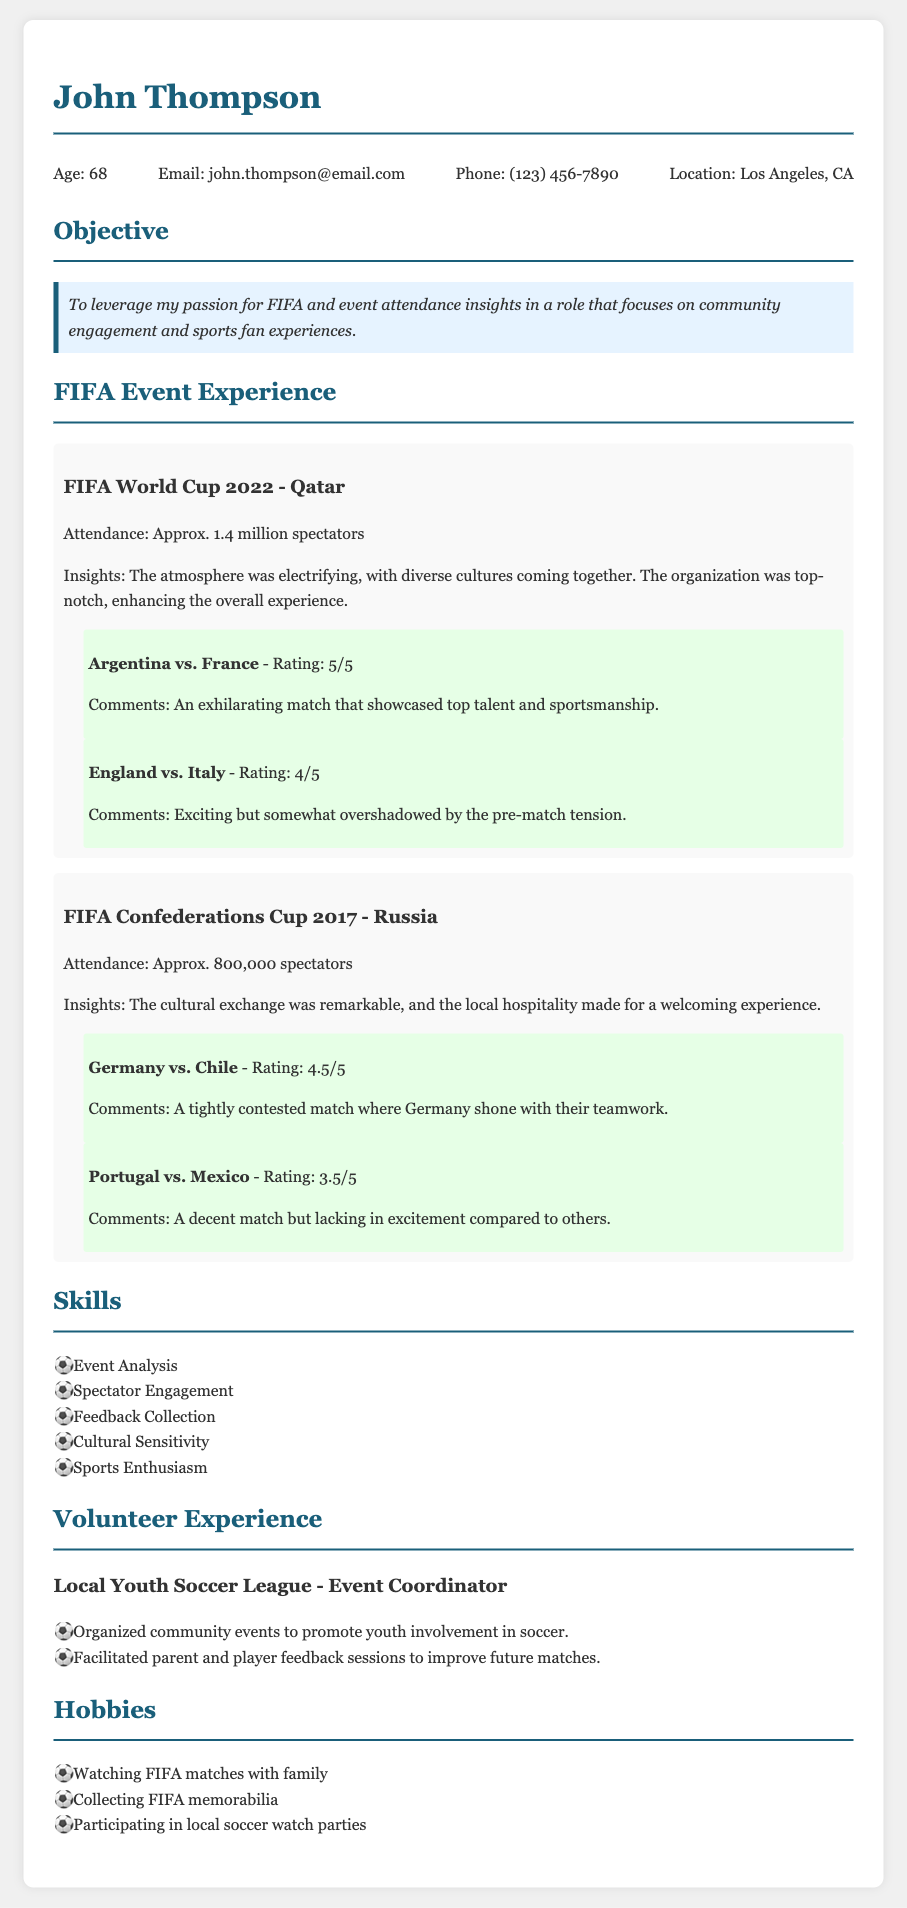what is the name of the person? The document is about John Thompson, as mentioned in the header.
Answer: John Thompson how old is John Thompson? The age of John is listed in the contact info section.
Answer: 68 what was the attendance at the FIFA World Cup 2022? The attendance figure for the FIFA World Cup 2022 can be found in the experience section.
Answer: Approx. 1.4 million spectators what was the rating for the match between Argentina and France? The rating for the match is provided in the experience section under the FIFA World Cup 2022.
Answer: 5/5 what insights were gained from the FIFA Confederations Cup 2017? Insights from this event are summarized in the experience section.
Answer: The cultural exchange was remarkable, and the local hospitality made for a welcoming experience which match had the lowest rating in the FIFA Confederations Cup 2017? The match ratings are listed in the experience item for the FIFA Confederations Cup 2017.
Answer: Portugal vs. Mexico what is one of John Thompson's hobbies? Hobbies are listed in a specific section of the document.
Answer: Watching FIFA matches with family what role did John Thompson have in the Local Youth Soccer League? His position is outlined in the volunteer experience section of the document.
Answer: Event Coordinator what skills does John Thompson highlight in his resume? Skills are presented in a list format under the skills section.
Answer: Event Analysis what was the pre-match atmosphere of the England vs. Italy match? The comments about the match provide insights on the atmosphere during the experience.
Answer: overshadowed by the pre-match tension 